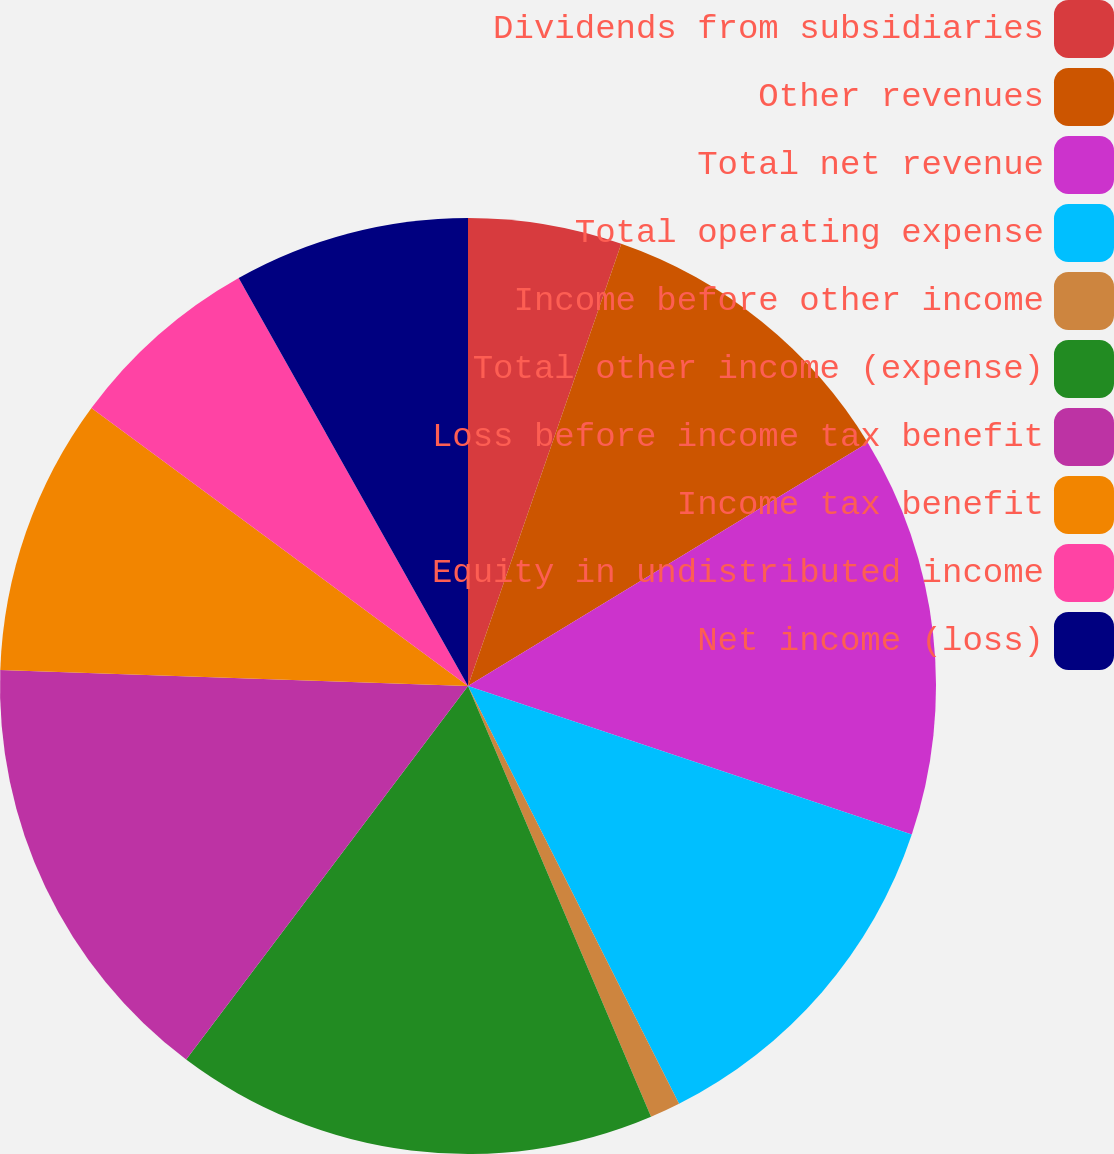Convert chart. <chart><loc_0><loc_0><loc_500><loc_500><pie_chart><fcel>Dividends from subsidiaries<fcel>Other revenues<fcel>Total net revenue<fcel>Total operating expense<fcel>Income before other income<fcel>Total other income (expense)<fcel>Loss before income tax benefit<fcel>Income tax benefit<fcel>Equity in undistributed income<fcel>Net income (loss)<nl><fcel>5.31%<fcel>10.99%<fcel>13.84%<fcel>12.41%<fcel>1.05%<fcel>16.68%<fcel>15.26%<fcel>9.57%<fcel>6.73%<fcel>8.15%<nl></chart> 